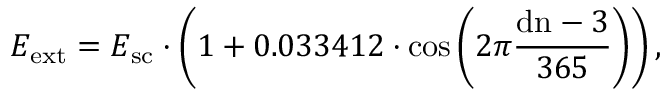Convert formula to latex. <formula><loc_0><loc_0><loc_500><loc_500>E _ { e x t } = E _ { s c } \cdot \left ( 1 + 0 . 0 3 3 4 1 2 \cdot \cos \left ( 2 \pi { \frac { { d n } - 3 } { 3 6 5 } } \right ) \right ) ,</formula> 